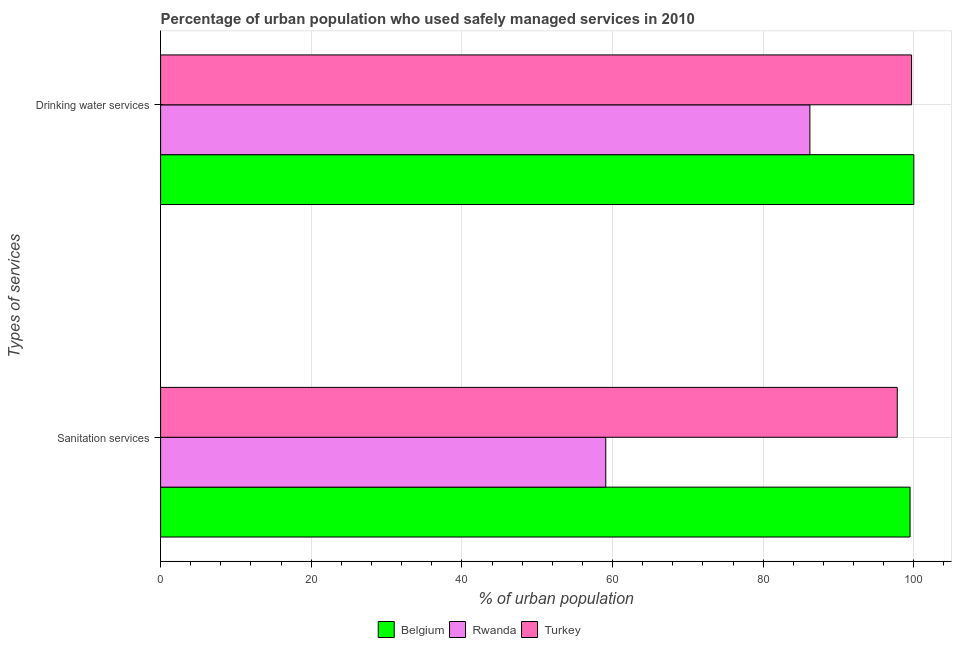How many different coloured bars are there?
Your answer should be very brief. 3. Are the number of bars on each tick of the Y-axis equal?
Give a very brief answer. Yes. What is the label of the 2nd group of bars from the top?
Give a very brief answer. Sanitation services. What is the percentage of urban population who used sanitation services in Turkey?
Your answer should be very brief. 97.8. Across all countries, what is the minimum percentage of urban population who used drinking water services?
Offer a very short reply. 86.2. In which country was the percentage of urban population who used drinking water services maximum?
Your answer should be compact. Belgium. In which country was the percentage of urban population who used sanitation services minimum?
Keep it short and to the point. Rwanda. What is the total percentage of urban population who used drinking water services in the graph?
Provide a succinct answer. 285.9. What is the difference between the percentage of urban population who used sanitation services in Rwanda and that in Turkey?
Offer a terse response. -38.7. What is the difference between the percentage of urban population who used drinking water services in Turkey and the percentage of urban population who used sanitation services in Belgium?
Keep it short and to the point. 0.2. What is the average percentage of urban population who used drinking water services per country?
Give a very brief answer. 95.3. What is the difference between the percentage of urban population who used drinking water services and percentage of urban population who used sanitation services in Rwanda?
Offer a very short reply. 27.1. In how many countries, is the percentage of urban population who used sanitation services greater than 96 %?
Make the answer very short. 2. What is the ratio of the percentage of urban population who used drinking water services in Rwanda to that in Belgium?
Offer a terse response. 0.86. What does the 2nd bar from the top in Sanitation services represents?
Offer a terse response. Rwanda. How many bars are there?
Provide a short and direct response. 6. Are all the bars in the graph horizontal?
Offer a very short reply. Yes. How many countries are there in the graph?
Your answer should be compact. 3. What is the difference between two consecutive major ticks on the X-axis?
Offer a terse response. 20. How are the legend labels stacked?
Offer a terse response. Horizontal. What is the title of the graph?
Offer a very short reply. Percentage of urban population who used safely managed services in 2010. Does "Antigua and Barbuda" appear as one of the legend labels in the graph?
Provide a short and direct response. No. What is the label or title of the X-axis?
Offer a terse response. % of urban population. What is the label or title of the Y-axis?
Offer a very short reply. Types of services. What is the % of urban population of Belgium in Sanitation services?
Give a very brief answer. 99.5. What is the % of urban population of Rwanda in Sanitation services?
Offer a very short reply. 59.1. What is the % of urban population in Turkey in Sanitation services?
Provide a short and direct response. 97.8. What is the % of urban population in Belgium in Drinking water services?
Provide a short and direct response. 100. What is the % of urban population in Rwanda in Drinking water services?
Your answer should be very brief. 86.2. What is the % of urban population of Turkey in Drinking water services?
Provide a succinct answer. 99.7. Across all Types of services, what is the maximum % of urban population in Belgium?
Provide a succinct answer. 100. Across all Types of services, what is the maximum % of urban population in Rwanda?
Offer a very short reply. 86.2. Across all Types of services, what is the maximum % of urban population of Turkey?
Provide a succinct answer. 99.7. Across all Types of services, what is the minimum % of urban population of Belgium?
Your answer should be very brief. 99.5. Across all Types of services, what is the minimum % of urban population in Rwanda?
Your answer should be very brief. 59.1. Across all Types of services, what is the minimum % of urban population in Turkey?
Offer a very short reply. 97.8. What is the total % of urban population of Belgium in the graph?
Make the answer very short. 199.5. What is the total % of urban population in Rwanda in the graph?
Your answer should be compact. 145.3. What is the total % of urban population in Turkey in the graph?
Make the answer very short. 197.5. What is the difference between the % of urban population in Rwanda in Sanitation services and that in Drinking water services?
Ensure brevity in your answer.  -27.1. What is the difference between the % of urban population in Turkey in Sanitation services and that in Drinking water services?
Your response must be concise. -1.9. What is the difference between the % of urban population in Belgium in Sanitation services and the % of urban population in Turkey in Drinking water services?
Provide a short and direct response. -0.2. What is the difference between the % of urban population of Rwanda in Sanitation services and the % of urban population of Turkey in Drinking water services?
Offer a very short reply. -40.6. What is the average % of urban population of Belgium per Types of services?
Keep it short and to the point. 99.75. What is the average % of urban population in Rwanda per Types of services?
Your answer should be very brief. 72.65. What is the average % of urban population of Turkey per Types of services?
Your response must be concise. 98.75. What is the difference between the % of urban population of Belgium and % of urban population of Rwanda in Sanitation services?
Your answer should be very brief. 40.4. What is the difference between the % of urban population of Rwanda and % of urban population of Turkey in Sanitation services?
Keep it short and to the point. -38.7. What is the ratio of the % of urban population of Belgium in Sanitation services to that in Drinking water services?
Keep it short and to the point. 0.99. What is the ratio of the % of urban population of Rwanda in Sanitation services to that in Drinking water services?
Give a very brief answer. 0.69. What is the ratio of the % of urban population of Turkey in Sanitation services to that in Drinking water services?
Your answer should be very brief. 0.98. What is the difference between the highest and the second highest % of urban population in Rwanda?
Offer a very short reply. 27.1. What is the difference between the highest and the second highest % of urban population of Turkey?
Your response must be concise. 1.9. What is the difference between the highest and the lowest % of urban population in Belgium?
Give a very brief answer. 0.5. What is the difference between the highest and the lowest % of urban population in Rwanda?
Provide a succinct answer. 27.1. 